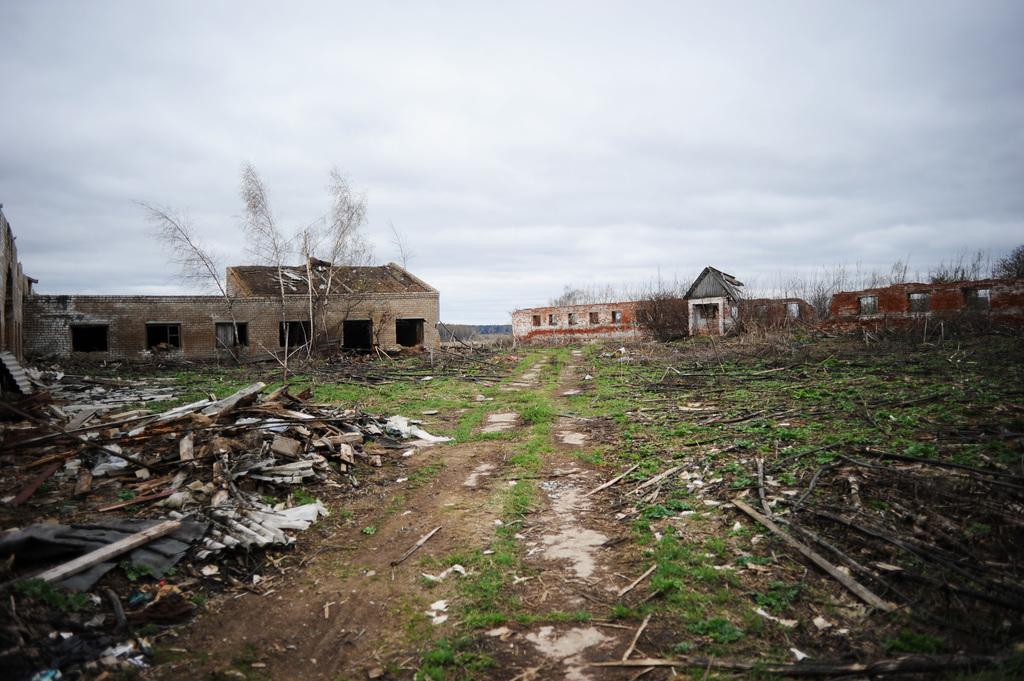What type of structures can be seen in the image? There are houses in the image. What type of vegetation is present in the image? There are trees in the image. What is visible at the top of the image? The sky is visible at the top of the image. What can be found on the ground at the bottom of the image? Twigs are present on the ground at the bottom of the image. Can you see the bear's toes in the image? There is no bear present in the image, so it is not possible to see the bear's toes. 